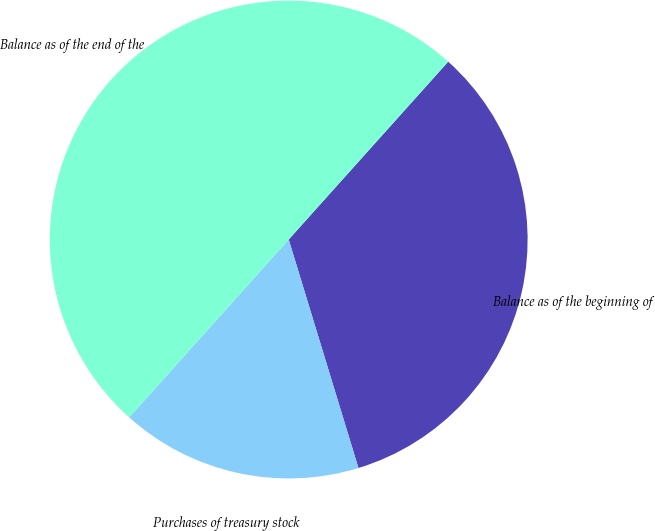Convert chart. <chart><loc_0><loc_0><loc_500><loc_500><pie_chart><fcel>Balance as of the beginning of<fcel>Purchases of treasury stock<fcel>Balance as of the end of the<nl><fcel>33.65%<fcel>16.35%<fcel>50.0%<nl></chart> 